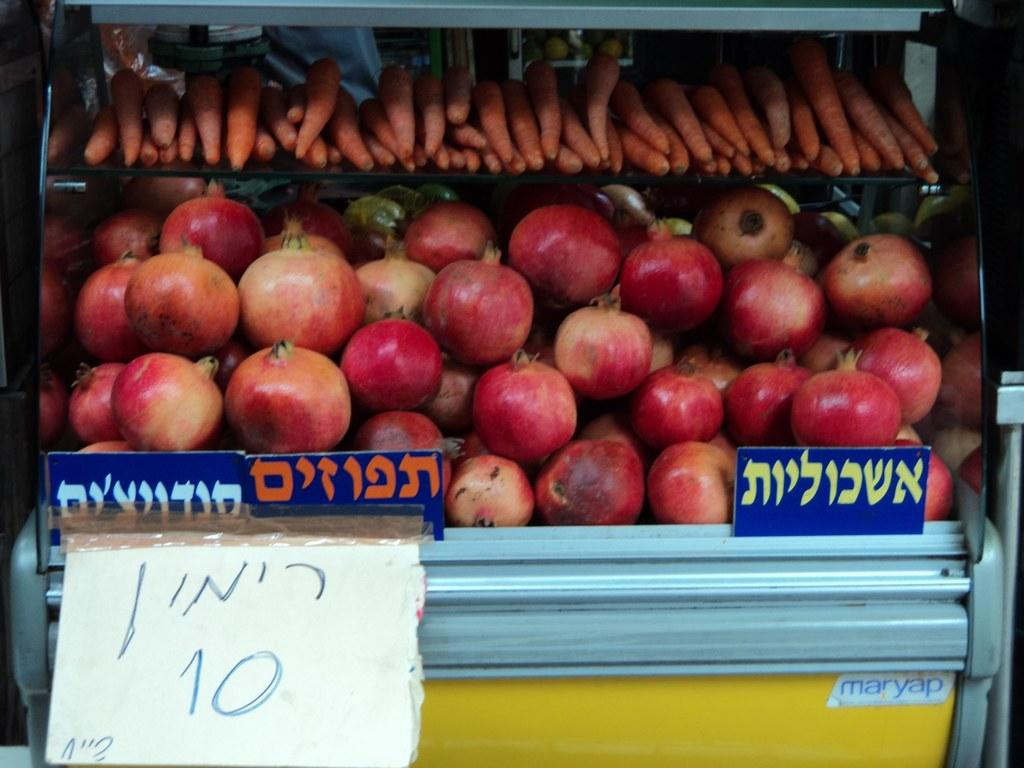What is the main subject in the foreground of the image? There is a glass object in the foreground of the image. What is associated with the glass object? There are boards and tags associated with the glass object. What is inside the glass object? Inside the glass, there are pomegranates and carrots. What type of agreement is being signed by the wrist in the image? There is no wrist or agreement present in the image. Is there a recess in the glass object in the image? The image does not show any recess in the glass object; it only shows pomegranates and carrots inside the glass. 